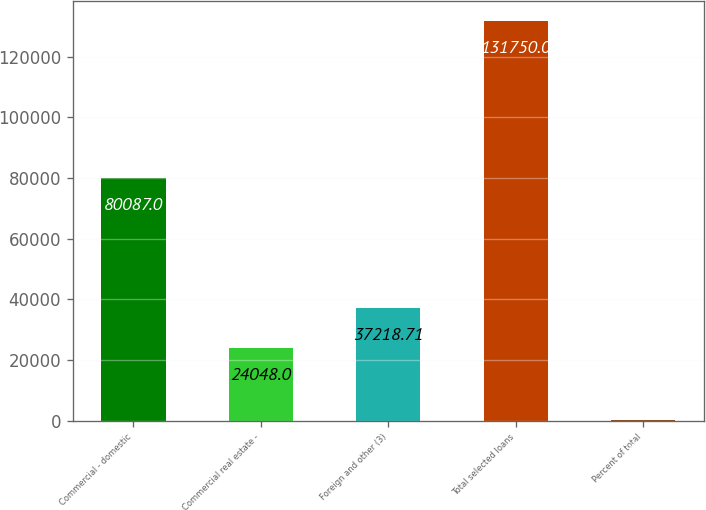Convert chart. <chart><loc_0><loc_0><loc_500><loc_500><bar_chart><fcel>Commercial - domestic<fcel>Commercial real estate -<fcel>Foreign and other (3)<fcel>Total selected loans<fcel>Percent of total<nl><fcel>80087<fcel>24048<fcel>37218.7<fcel>131750<fcel>42.9<nl></chart> 